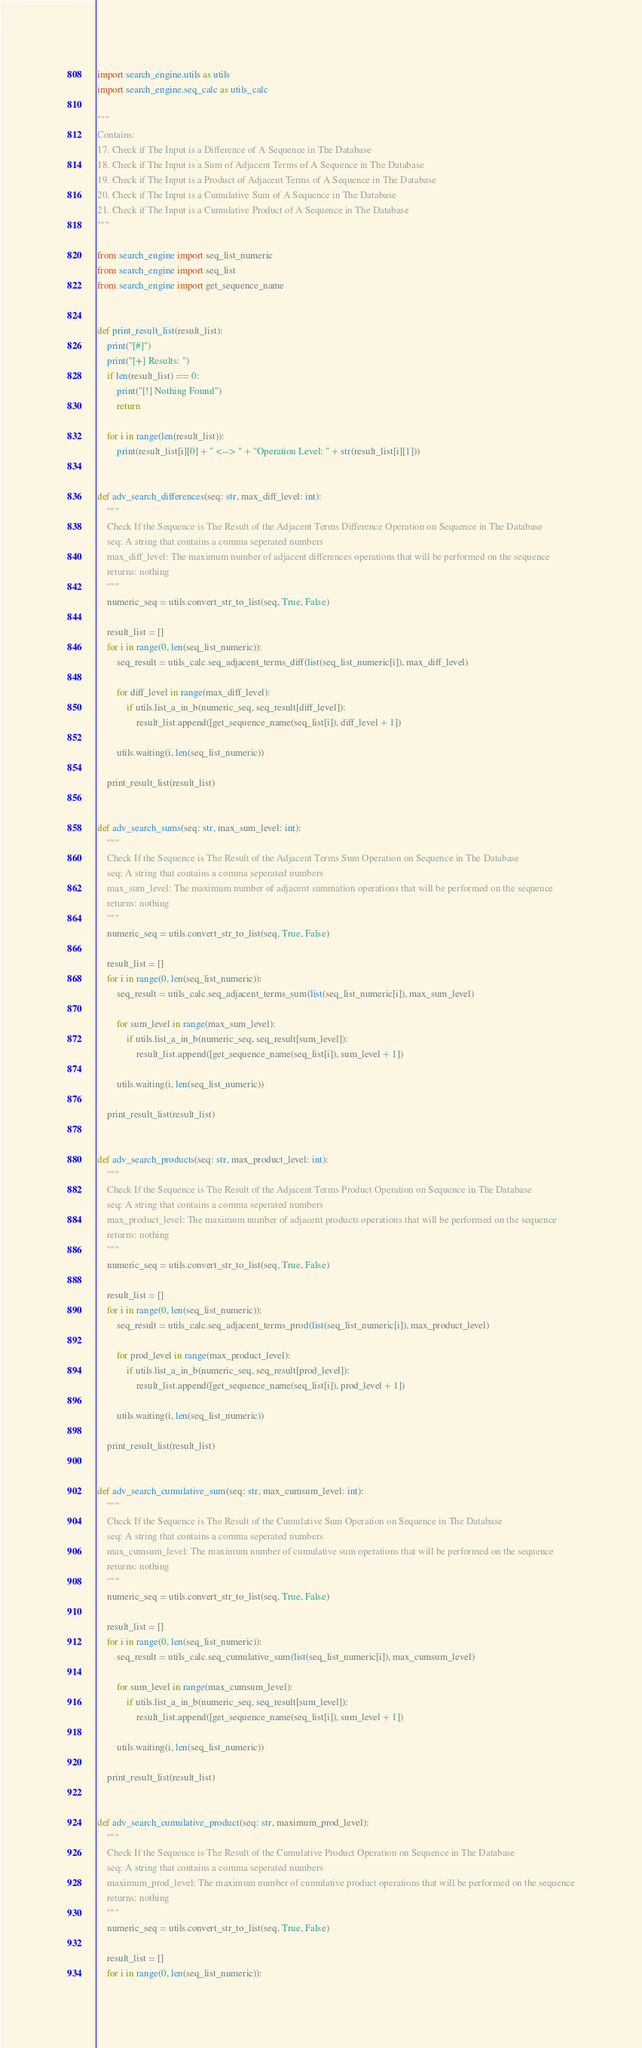Convert code to text. <code><loc_0><loc_0><loc_500><loc_500><_Python_>import search_engine.utils as utils
import search_engine.seq_calc as utils_calc

"""
Contains:
17. Check if The Input is a Difference of A Sequence in The Database
18. Check if The Input is a Sum of Adjacent Terms of A Sequence in The Database
19. Check if The Input is a Product of Adjacent Terms of A Sequence in The Database
20. Check if The Input is a Cumulative Sum of A Sequence in The Database
21. Check if The Input is a Cumulative Product of A Sequence in The Database
"""

from search_engine import seq_list_numeric
from search_engine import seq_list
from search_engine import get_sequence_name


def print_result_list(result_list):
    print("[#]")
    print("[+] Results: ")
    if len(result_list) == 0:
        print("[!] Nothing Found")
        return

    for i in range(len(result_list)):
        print(result_list[i][0] + " <--> " + "Operation Level: " + str(result_list[i][1]))


def adv_search_differences(seq: str, max_diff_level: int):
    """
    Check If the Sequence is The Result of the Adjacent Terms Difference Operation on Sequence in The Database
    seq: A string that contains a comma seperated numbers
    max_diff_level: The maximum number of adjacent differences operations that will be performed on the sequence
    returns: nothing
    """
    numeric_seq = utils.convert_str_to_list(seq, True, False)

    result_list = []
    for i in range(0, len(seq_list_numeric)):
        seq_result = utils_calc.seq_adjacent_terms_diff(list(seq_list_numeric[i]), max_diff_level)

        for diff_level in range(max_diff_level):
            if utils.list_a_in_b(numeric_seq, seq_result[diff_level]):
                result_list.append([get_sequence_name(seq_list[i]), diff_level + 1])

        utils.waiting(i, len(seq_list_numeric))

    print_result_list(result_list)


def adv_search_sums(seq: str, max_sum_level: int):
    """
    Check If the Sequence is The Result of the Adjacent Terms Sum Operation on Sequence in The Database
    seq: A string that contains a comma seperated numbers
    max_sum_level: The maximum number of adjacent summation operations that will be performed on the sequence
    returns: nothing
    """
    numeric_seq = utils.convert_str_to_list(seq, True, False)

    result_list = []
    for i in range(0, len(seq_list_numeric)):
        seq_result = utils_calc.seq_adjacent_terms_sum(list(seq_list_numeric[i]), max_sum_level)

        for sum_level in range(max_sum_level):
            if utils.list_a_in_b(numeric_seq, seq_result[sum_level]):
                result_list.append([get_sequence_name(seq_list[i]), sum_level + 1])

        utils.waiting(i, len(seq_list_numeric))

    print_result_list(result_list)


def adv_search_products(seq: str, max_product_level: int):
    """
    Check If the Sequence is The Result of the Adjacent Terms Product Operation on Sequence in The Database
    seq: A string that contains a comma seperated numbers
    max_product_level: The maximum number of adjacent products operations that will be performed on the sequence
    returns: nothing
    """
    numeric_seq = utils.convert_str_to_list(seq, True, False)

    result_list = []
    for i in range(0, len(seq_list_numeric)):
        seq_result = utils_calc.seq_adjacent_terms_prod(list(seq_list_numeric[i]), max_product_level)

        for prod_level in range(max_product_level):
            if utils.list_a_in_b(numeric_seq, seq_result[prod_level]):
                result_list.append([get_sequence_name(seq_list[i]), prod_level + 1])

        utils.waiting(i, len(seq_list_numeric))

    print_result_list(result_list)


def adv_search_cumulative_sum(seq: str, max_cumsum_level: int):
    """
    Check If the Sequence is The Result of the Cumulative Sum Operation on Sequence in The Database
    seq: A string that contains a comma seperated numbers
    max_cumsum_level: The maximum number of cumulative sum operations that will be performed on the sequence
    returns: nothing
    """
    numeric_seq = utils.convert_str_to_list(seq, True, False)

    result_list = []
    for i in range(0, len(seq_list_numeric)):
        seq_result = utils_calc.seq_cumulative_sum(list(seq_list_numeric[i]), max_cumsum_level)

        for sum_level in range(max_cumsum_level):
            if utils.list_a_in_b(numeric_seq, seq_result[sum_level]):
                result_list.append([get_sequence_name(seq_list[i]), sum_level + 1])

        utils.waiting(i, len(seq_list_numeric))

    print_result_list(result_list)


def adv_search_cumulative_product(seq: str, maximum_prod_level):
    """
    Check If the Sequence is The Result of the Cumulative Product Operation on Sequence in The Database
    seq: A string that contains a comma seperated numbers
    maximum_prod_level: The maximum number of cumulative product operations that will be performed on the sequence
    returns: nothing
    """
    numeric_seq = utils.convert_str_to_list(seq, True, False)

    result_list = []
    for i in range(0, len(seq_list_numeric)):</code> 